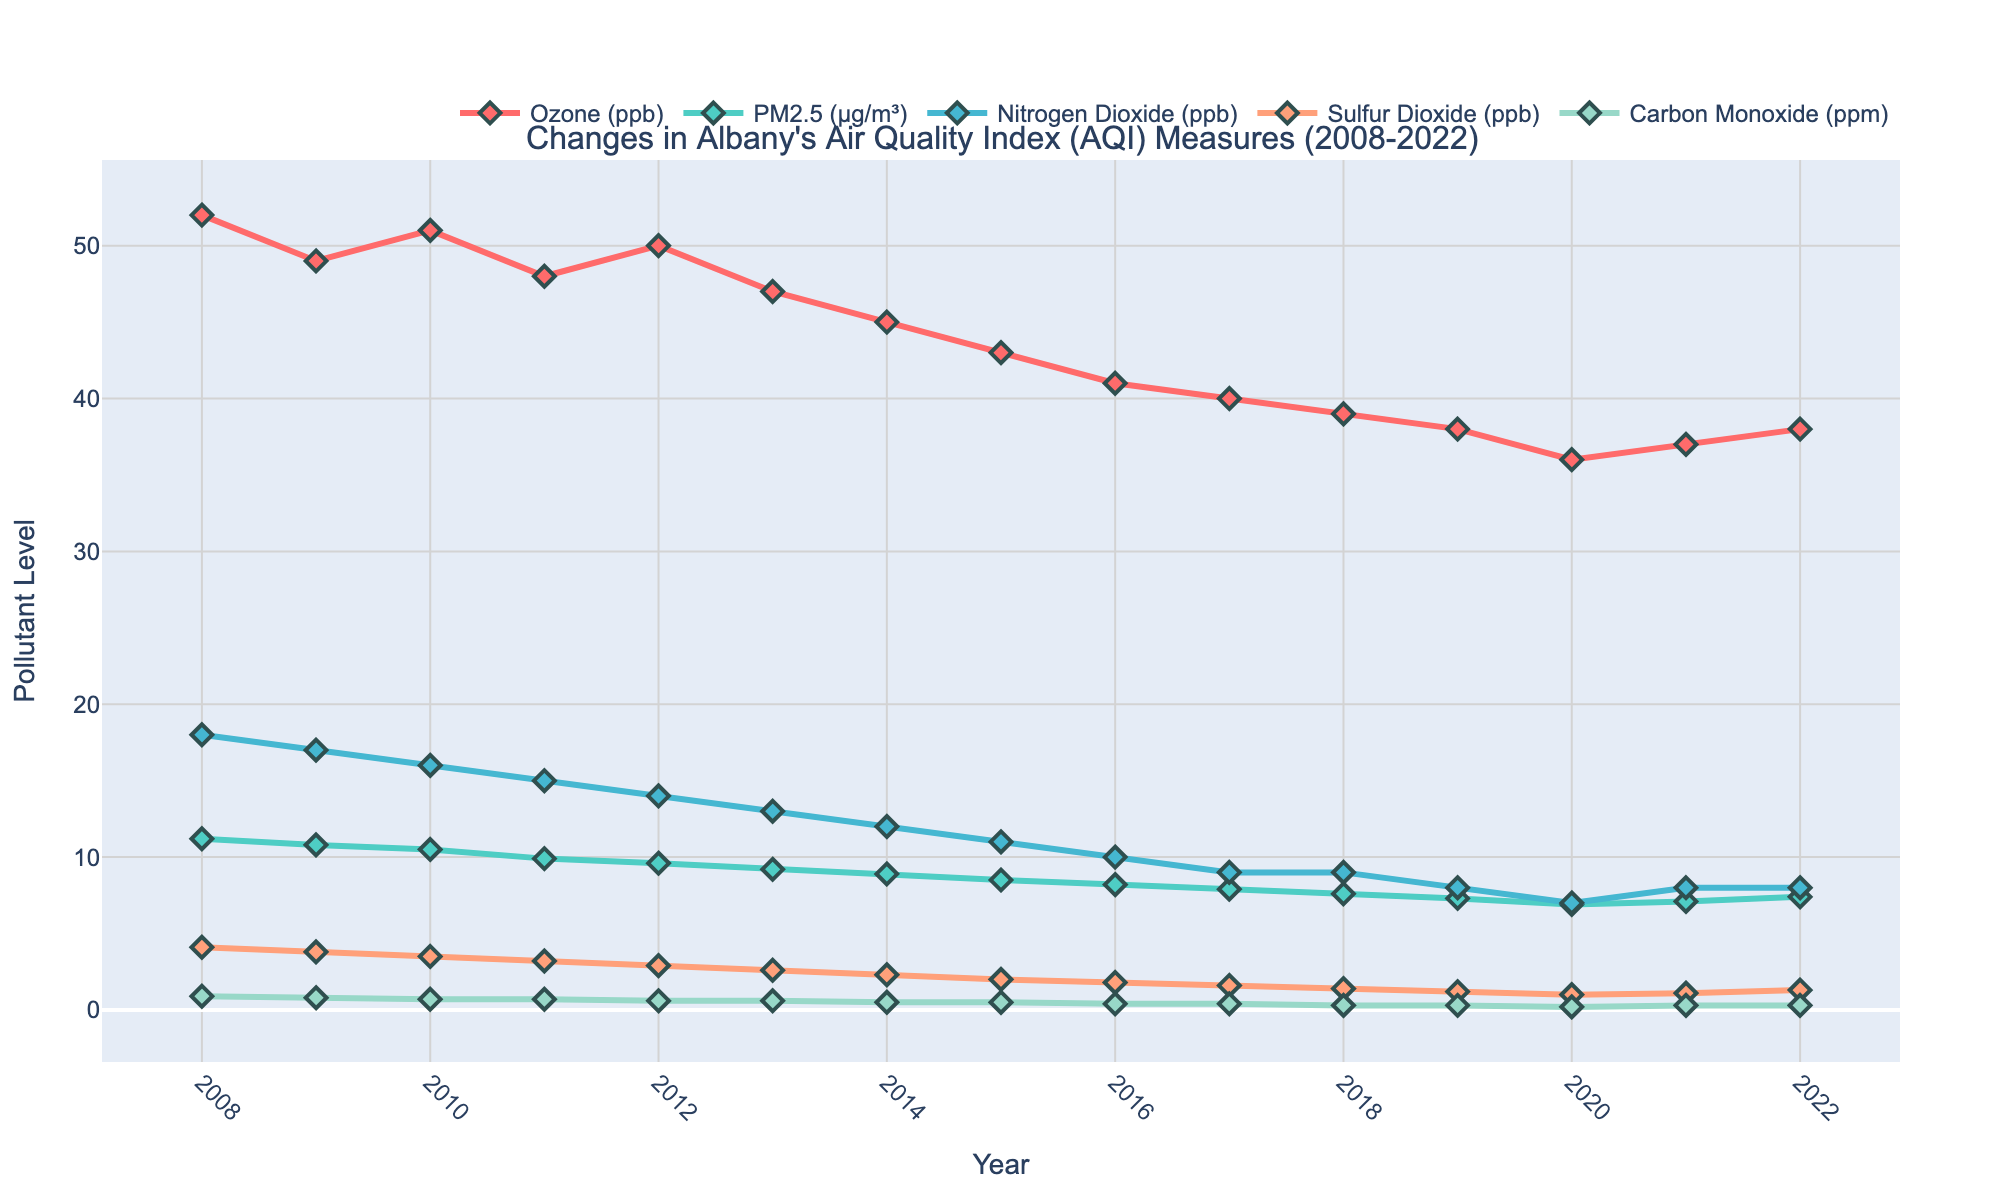What is the general trend of the Ozone levels over the past 15 years? The Ozone levels show a general decrease from 52 ppb in 2008 to 38 ppb in 2022.
Answer: Decreasing In which year was the PM2.5 level the lowest? The PM2.5 level was the lowest in 2020, where it was 6.9 μg/m³.
Answer: 2020 How do Nitrogen Dioxide levels in 2011 compare to those in 2021? In 2011, the Nitrogen Dioxide level was 15 ppb, and in 2021, it was 8 ppb. Thus, Nitrogen Dioxide levels in 2011 were higher than in 2021.
Answer: Higher in 2011 What is the average Sulfur Dioxide level between 2008 and 2022? Adding Sulfur Dioxide levels from 2008 to 2022 and then dividing by the number of years: (4.1 + 3.8 + 3.5 + 3.2 + 2.9 + 2.6 + 2.3 + 2.0 + 1.8 + 1.6 + 1.4 + 1.2 + 1.0 + 1.1 + 1.3) / 15 = 2.2 ppb.
Answer: 2.2 ppb Between which years did Carbon Monoxide levels drop the most significantly? Carbon Monoxide levels show the most significant drop between 2008 and 2009, from 0.9 ppm to 0.8 ppm.
Answer: 2008 to 2009 Compare the trends of PM2.5 and Nitrogen Dioxide levels from 2008 to 2022. Both PM2.5 and Nitrogen Dioxide levels show a decreasing trend over the years. PM2.5 decreases from 11.2 μg/m³ to 7.4 μg/m³, and Nitrogen Dioxide decreases from 18 ppb to 8 ppb.
Answer: Both decreasing Which pollutant shows the most noticeable reduction in levels and over what range of years? Carbon Monoxide shows the most noticeable reduction from 0.9 ppm in 2008 to 0.3 ppm in 2022.
Answer: Carbon Monoxide In 2022, which pollutant had the closest levels to those in 2012? Nitrogen Dioxide had levels of 14 ppb in 2012 and 8 ppb in 2022. No other pollutant was as close in proximity over these years.
Answer: Nitrogen Dioxide What trend can be observed for Sulfur Dioxide levels from 2008 to 2016? Sulfur Dioxide levels show a steady decrease from 4.1 ppb in 2008 to 1.8 ppb in 2016.
Answer: Decreasing 